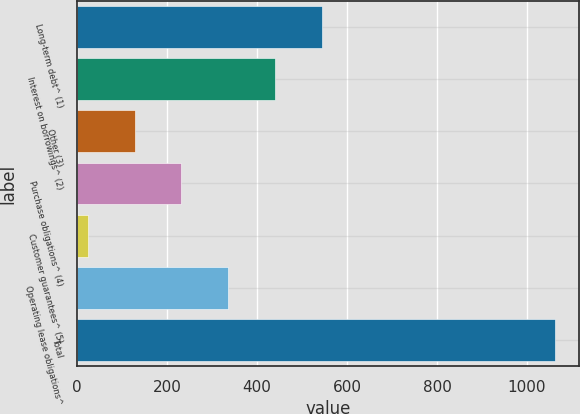Convert chart to OTSL. <chart><loc_0><loc_0><loc_500><loc_500><bar_chart><fcel>Long-term debt^ (1)<fcel>Interest on borrowings^ (2)<fcel>Other (3)<fcel>Purchase obligations^ (4)<fcel>Customer guarantees^ (5)<fcel>Operating lease obligations^<fcel>Total<nl><fcel>543.5<fcel>439.6<fcel>127.9<fcel>231.8<fcel>24<fcel>335.7<fcel>1063<nl></chart> 